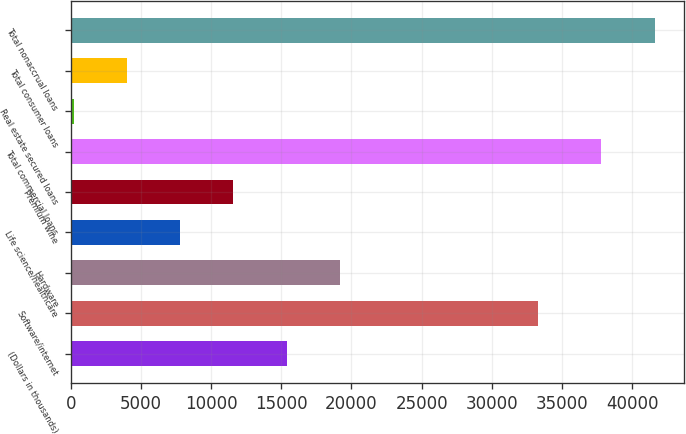Convert chart. <chart><loc_0><loc_0><loc_500><loc_500><bar_chart><fcel>(Dollars in thousands)<fcel>Software/internet<fcel>Hardware<fcel>Life science/healthcare<fcel>Premium wine<fcel>Total commercial loans<fcel>Real estate secured loans<fcel>Total consumer loans<fcel>Total nonaccrual loans<nl><fcel>15370<fcel>33287<fcel>19164.5<fcel>7781<fcel>11575.5<fcel>37820<fcel>192<fcel>3986.5<fcel>41614.5<nl></chart> 